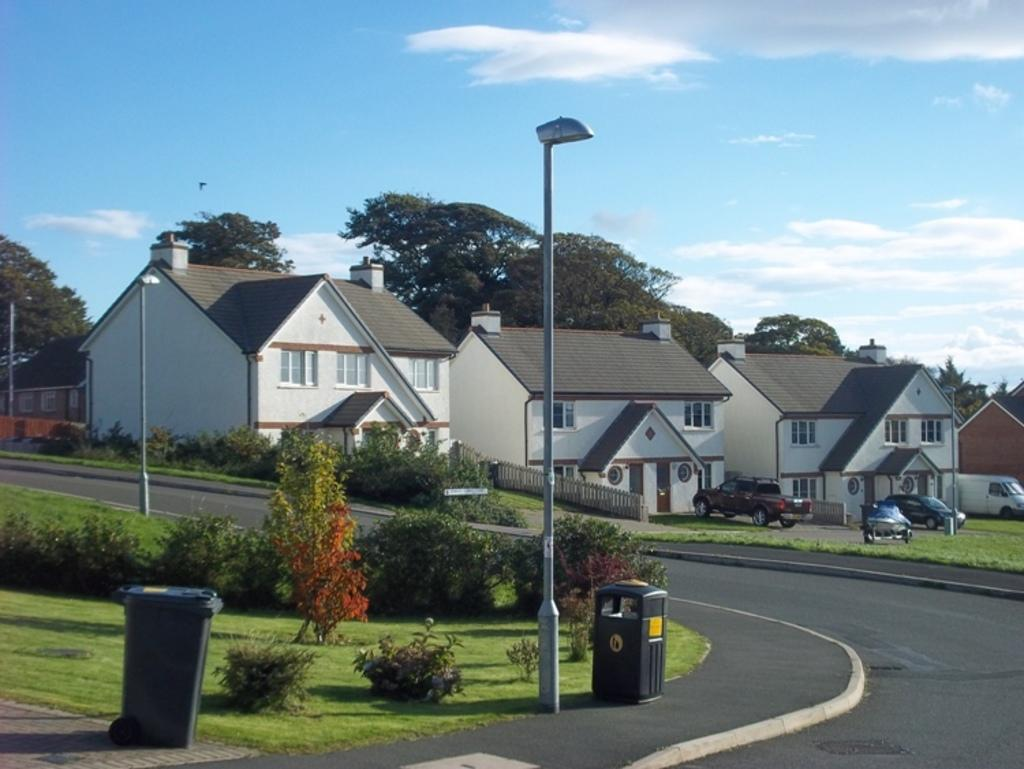What structures are located in the center of the image? There are sheds in the center of the image. What objects can be seen in the image besides the sheds? There are poles and bins visible in the image. What type of vegetation is present at the bottom of the image? There are bushes at the bottom of the image. What can be seen in the background of the image? There are cars, trees, and the sky visible in the background of the image. What type of vacation is being planned by the bushes in the image? There is no indication in the image that the bushes are planning a vacation, as bushes do not have the ability to plan vacations. 